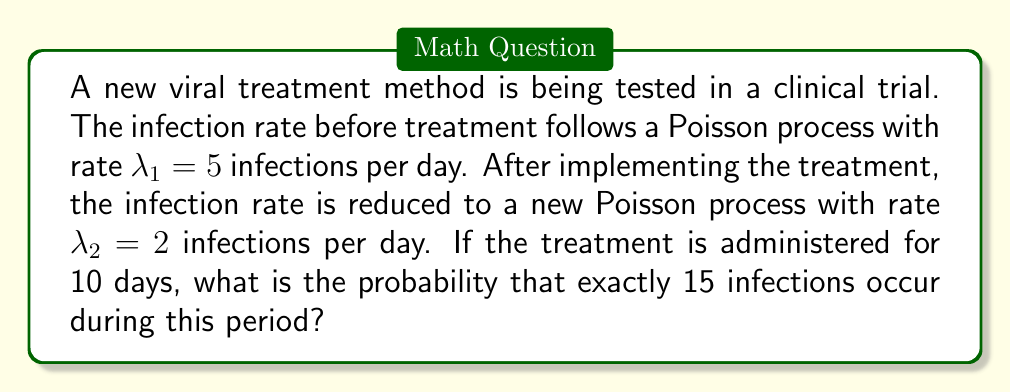Provide a solution to this math problem. Let's approach this step-by-step:

1) The number of infections over a period of time in a Poisson process follows a Poisson distribution. The parameter of this distribution is $\lambda t$, where $\lambda$ is the rate and $t$ is the time period.

2) In this case, we have a Poisson process with rate $\lambda_2 = 2$ infections per day for a period of $t = 10$ days.

3) The parameter of the Poisson distribution is therefore $\lambda t = 2 \times 10 = 20$.

4) The probability of exactly $k$ events occurring in a Poisson distribution with parameter $\lambda$ is given by:

   $$P(X = k) = \frac{e^{-\lambda} \lambda^k}{k!}$$

5) In our case, $k = 15$ and $\lambda = 20$. Let's substitute these values:

   $$P(X = 15) = \frac{e^{-20} 20^{15}}{15!}$$

6) Calculating this (you can use a calculator or computer for this step):

   $$P(X = 15) \approx 0.0516$$

7) Therefore, the probability of exactly 15 infections occurring during the 10-day treatment period is approximately 0.0516 or 5.16%.
Answer: 0.0516 